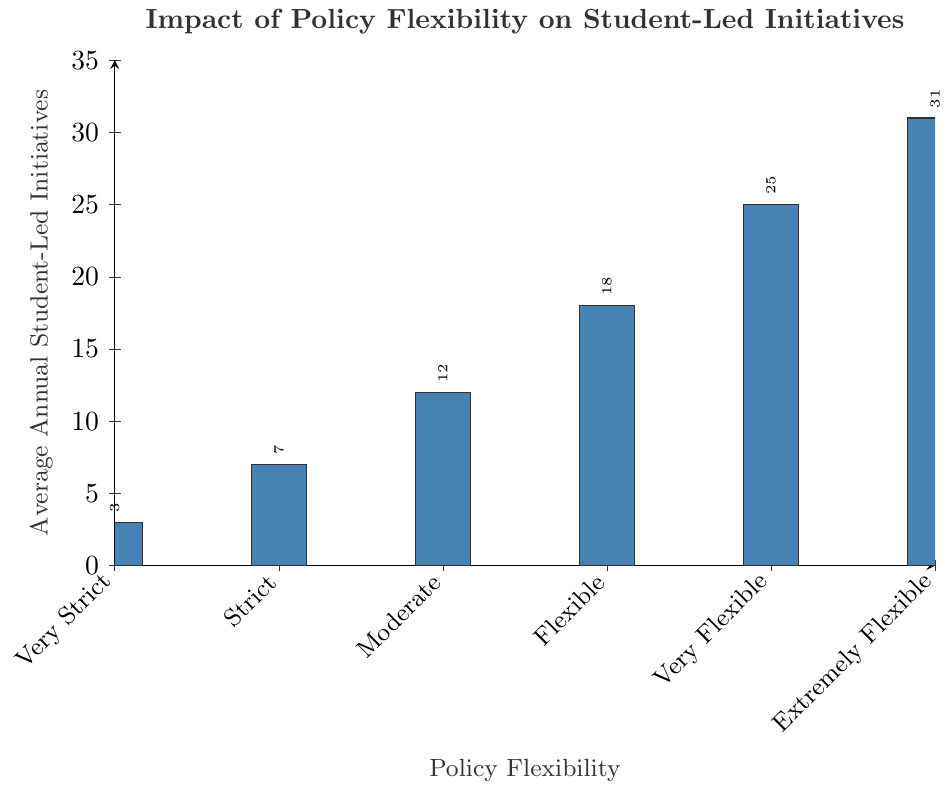What is the difference in the average annual student-led initiatives between schools with Very Strict and Extremely Flexible policies? In the figure, Very Strict policies correspond to 3 initiatives and Extremely Flexible policies correspond to 31 initiatives. The difference is calculated as 31 - 3.
Answer: 28 Which degree of policy flexibility corresponds to the highest average annual student-led initiatives? The bar corresponding to Extremely Flexible policies has the highest value at 31.
Answer: Extremely Flexible How many more initiatives are there on average in schools with Moderate policies compared to those with Strict policies? Schools with Moderate policies have 12 initiatives, while those with Strict policies have 7. The difference is calculated as 12 - 7.
Answer: 5 What is the average number of student-led initiatives for schools with Moderate, Flexible, and Very Flexible policies? Add the values for Moderate (12), Flexible (18), and Very Flexible (25), then divide by 3 to get the average: (12 + 18 + 25) / 3.
Answer: 18.33 Is there a clear trend in the average annual student-led initiatives as the policy flexibility increases? If so, what is the trend? The figure shows an increasing trend in average student-led initiatives as policy flexibility increases, ranging from 3 for Very Strict to 31 for Extremely Flexible.
Answer: Increasing What is the ratio of average student-led initiatives between Extremely Flexible and Very Strict policies? The average initiatives for Extremely Flexible policies are 31, and for Very Strict policies are 3. The ratio is calculated as 31 / 3.
Answer: 10.33 Which degree of policy flexibility shows the smallest increase in student-led initiatives compared to the previous level? The smallest increase is between Very Strict (3) and Strict (7). The increase is calculated as 7 - 3 = 4.
Answer: Strict vs Very Strict Compare the average number of initiatives in schools with Flexible and Very Flexible policies. The average number for Flexible policies is 18, whereas for Very Flexible, it is 25.
Answer: 18 vs 25 How does the bar color influence the interpretation of the chart? The consistent bar color, a shade of blue, helps in quickly identifying and comparing the heights of the bars representing different policy flexibilities.
Answer: Clear comparison 